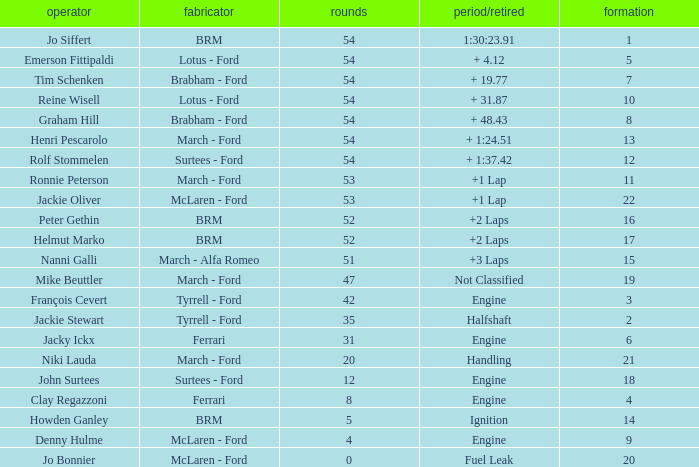What is the average grid that has over 8 laps, a Time/Retired of +2 laps, and peter gethin driving? 16.0. 